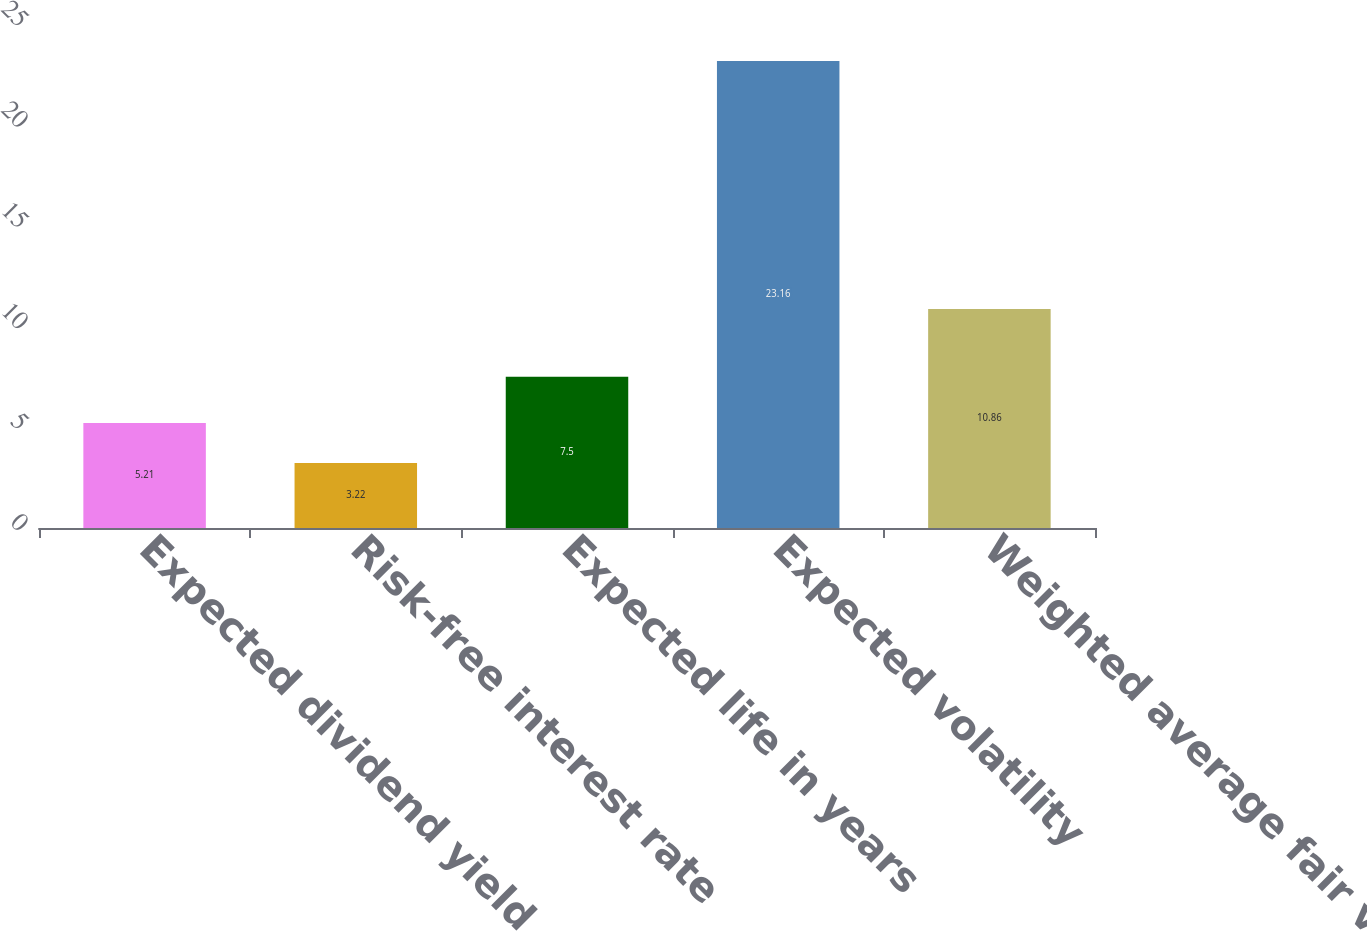Convert chart. <chart><loc_0><loc_0><loc_500><loc_500><bar_chart><fcel>Expected dividend yield<fcel>Risk-free interest rate<fcel>Expected life in years<fcel>Expected volatility<fcel>Weighted average fair value of<nl><fcel>5.21<fcel>3.22<fcel>7.5<fcel>23.16<fcel>10.86<nl></chart> 